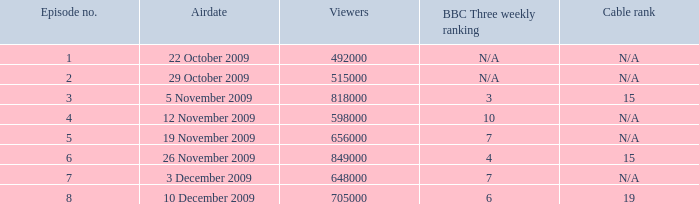How many viewers were there for airdate is 22 october 2009? 492000.0. 